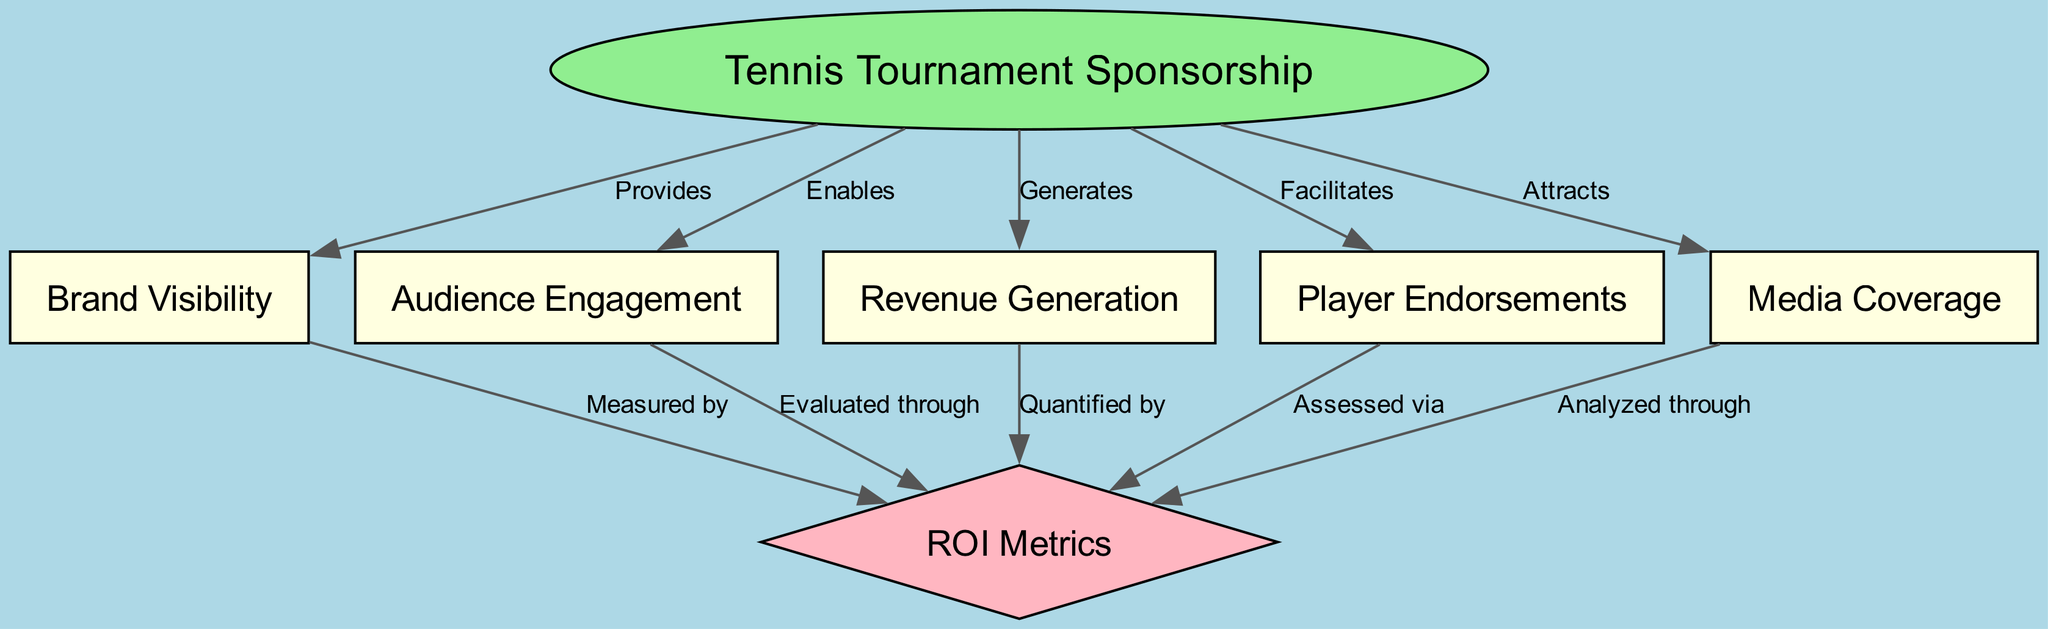What is the main node in the diagram? The main node is "Tennis Tournament Sponsorship," which serves as the central concept from which all other nodes branch out. This can be confirmed by looking for the node that has multiple outgoing edges to other nodes.
Answer: Tennis Tournament Sponsorship How many nodes are present in the diagram? By counting all the nodes listed, there are seven distinct nodes interconnected in this concept map, each representing different aspects of tennis tournament sponsorship.
Answer: Seven What relationship exists between "Tennis Tournament Sponsorship" and "Brand Visibility"? The relationship is that "Tennis Tournament Sponsorship" provides "Brand Visibility," as indicated by the directed edge leading from the first node to the second node, showcasing the connection.
Answer: Provides Which node is connected to "Player Endorsements"? The node "Tennis Tournament Sponsorship" directly connects to "Player Endorsements," indicating a relationship where sponsorship facilitates endorsements for players. This can be seen from the respective edge.
Answer: Tennis Tournament Sponsorship How is "Audience Engagement" evaluated? "Audience Engagement" is evaluated through ROI metrics, as indicated by the directed edge flowing from "Audience Engagement" to "ROI Metrics," showcasing a method of assessment.
Answer: Evaluated through What are the five factors that lead to measuring the ROI metrics? The five factors that contribute to measuring ROI metrics include "Brand Visibility," "Audience Engagement," "Revenue Generation," "Player Endorsements," and "Media Coverage," as they all connect to the ROI Metrics node through different edges.
Answer: Brand Visibility, Audience Engagement, Revenue Generation, Player Endorsements, Media Coverage What type of node is "ROI Metrics"? "ROI Metrics" is a diamond-shaped node in this diagram, which typically represents outcomes or evaluations in a concept map structure, distinguishing it from other types of nodes.
Answer: Diamond How does "Media Coverage" relate to "ROI Metrics"? The relationship is that "Media Coverage" is analyzed through "ROI Metrics," shown by the edge directed from the sixth node to the diamond-shaped node, indicating a specific way to assess media impact on ROI.
Answer: Analyzed through 